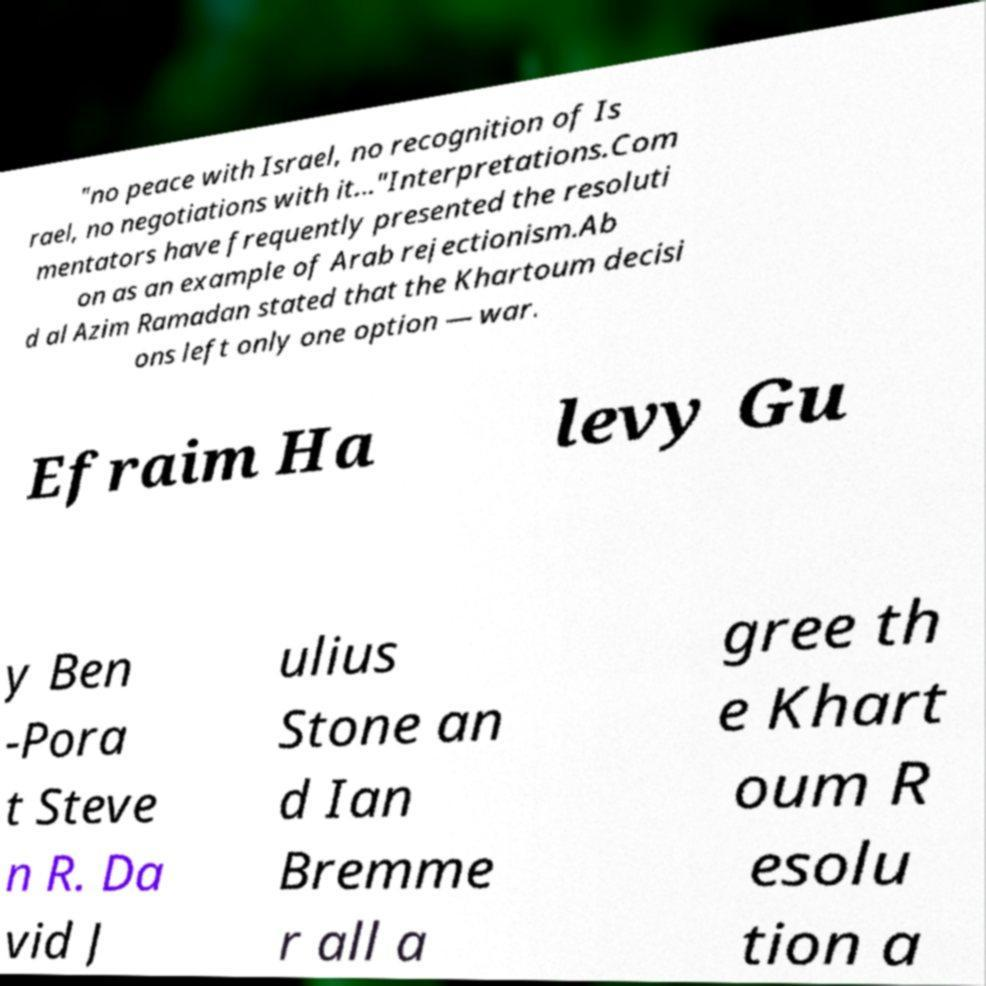Could you assist in decoding the text presented in this image and type it out clearly? "no peace with Israel, no recognition of Is rael, no negotiations with it..."Interpretations.Com mentators have frequently presented the resoluti on as an example of Arab rejectionism.Ab d al Azim Ramadan stated that the Khartoum decisi ons left only one option — war. Efraim Ha levy Gu y Ben -Pora t Steve n R. Da vid J ulius Stone an d Ian Bremme r all a gree th e Khart oum R esolu tion a 